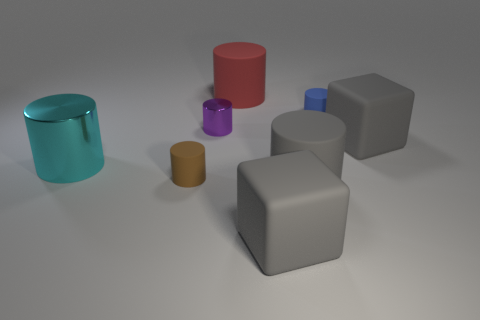Subtract all blue cylinders. How many cylinders are left? 5 Subtract all metal cylinders. How many cylinders are left? 4 Subtract all green cylinders. Subtract all blue spheres. How many cylinders are left? 6 Add 1 big cyan metallic things. How many objects exist? 9 Subtract all cylinders. How many objects are left? 2 Add 4 tiny red shiny spheres. How many tiny red shiny spheres exist? 4 Subtract 0 blue spheres. How many objects are left? 8 Subtract all tiny matte things. Subtract all tiny blue matte objects. How many objects are left? 5 Add 1 tiny brown objects. How many tiny brown objects are left? 2 